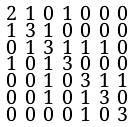<formula> <loc_0><loc_0><loc_500><loc_500>\begin{smallmatrix} 2 & 1 & 0 & 1 & 0 & 0 & 0 \\ 1 & 3 & 1 & 0 & 0 & 0 & 0 \\ 0 & 1 & 3 & 1 & 1 & 1 & 0 \\ 1 & 0 & 1 & 3 & 0 & 0 & 0 \\ 0 & 0 & 1 & 0 & 3 & 1 & 1 \\ 0 & 0 & 1 & 0 & 1 & 3 & 0 \\ 0 & 0 & 0 & 0 & 1 & 0 & 3 \end{smallmatrix}</formula> 